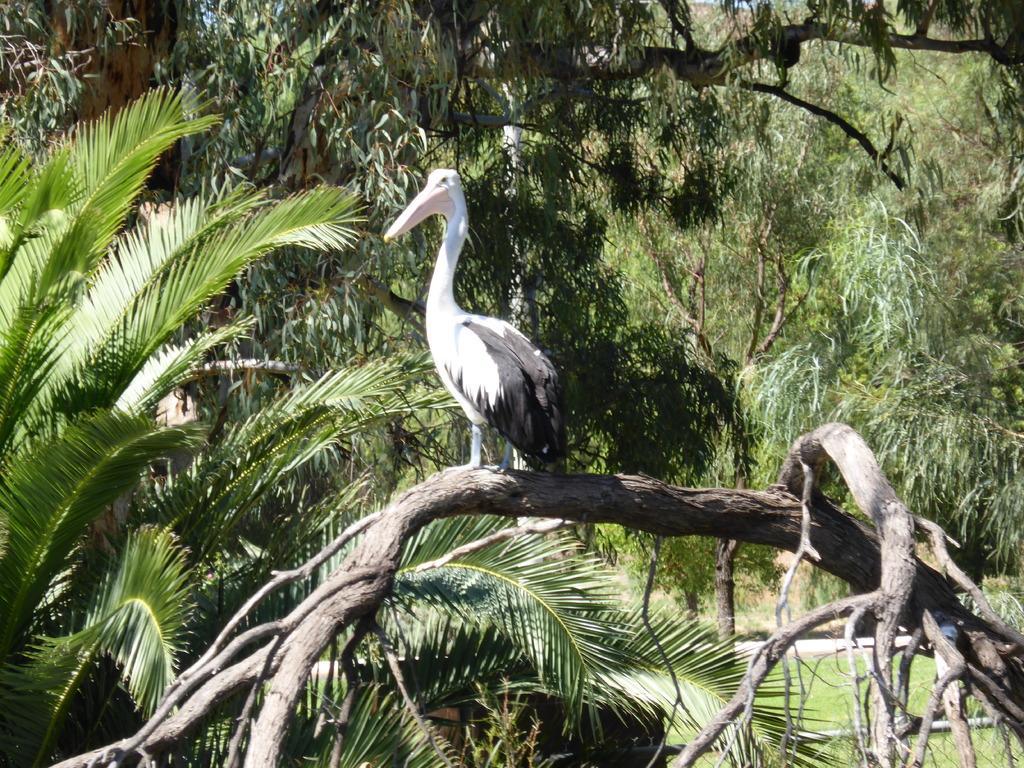Could you give a brief overview of what you see in this image? Bird is on the branch. Background there are trees. 